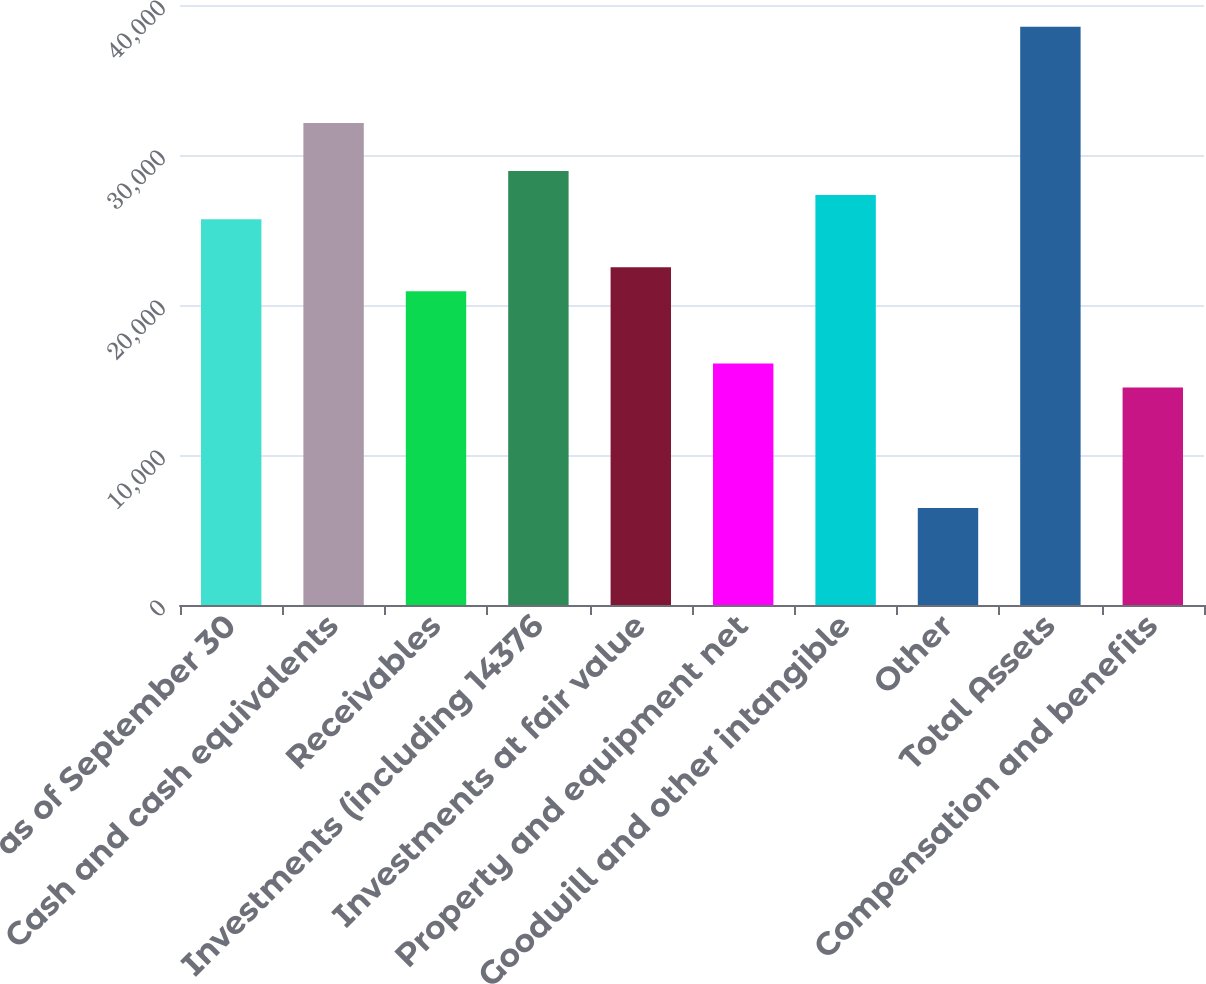<chart> <loc_0><loc_0><loc_500><loc_500><bar_chart><fcel>as of September 30<fcel>Cash and cash equivalents<fcel>Receivables<fcel>Investments (including 14376<fcel>Investments at fair value<fcel>Property and equipment net<fcel>Goodwill and other intangible<fcel>Other<fcel>Total Assets<fcel>Compensation and benefits<nl><fcel>25723.9<fcel>32140.6<fcel>20911.3<fcel>28932.2<fcel>22515.5<fcel>16098.8<fcel>27328.1<fcel>6473.72<fcel>38557.3<fcel>14494.6<nl></chart> 